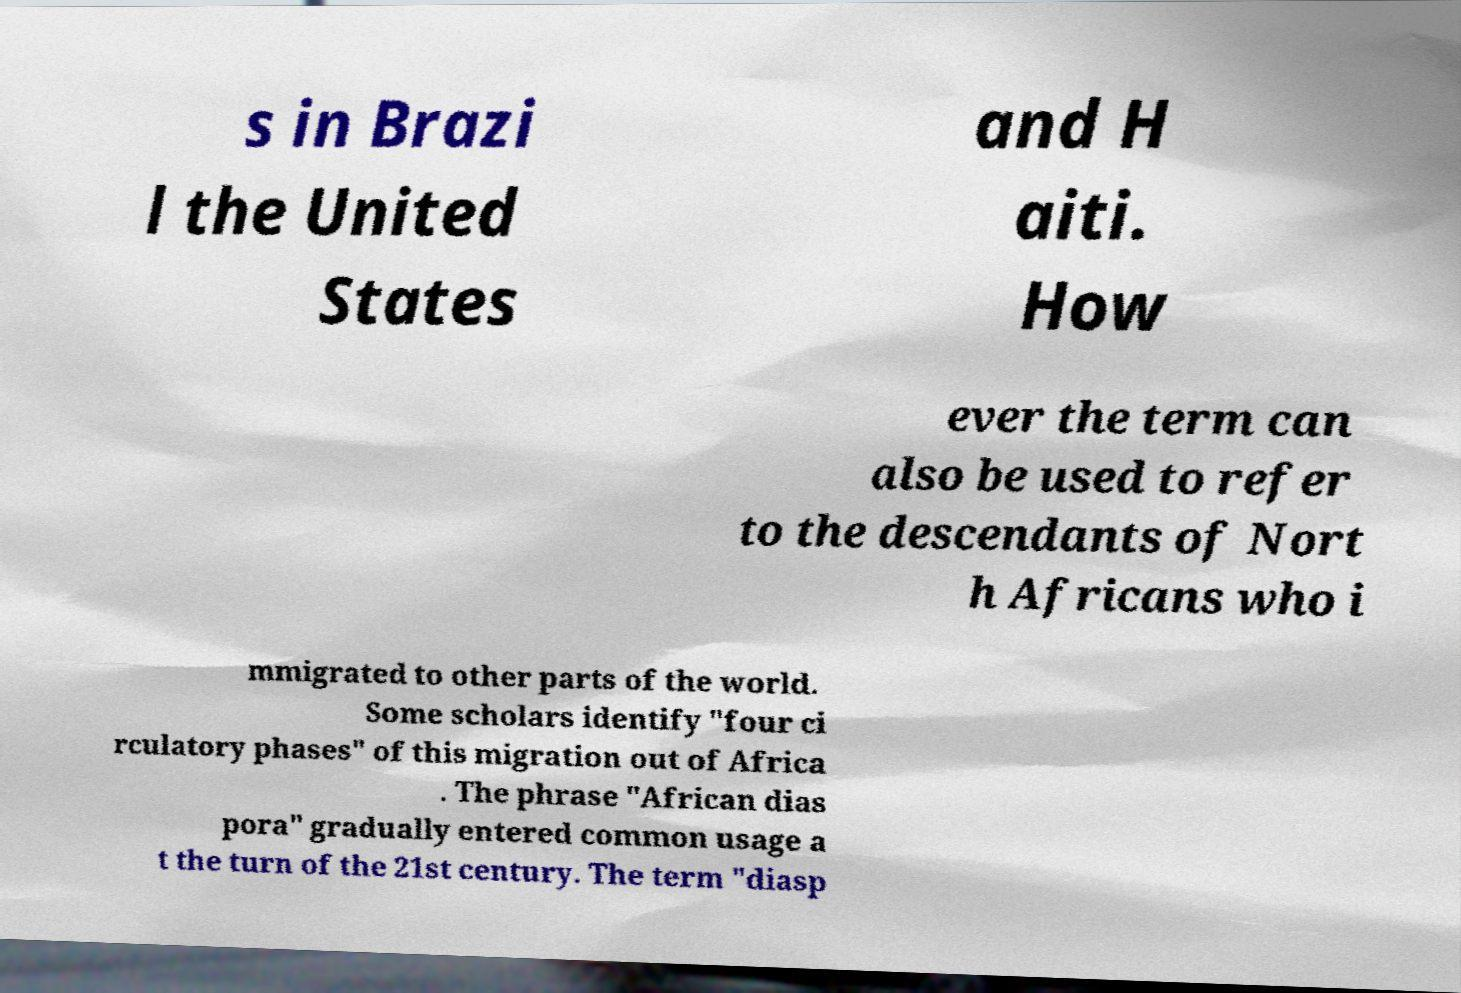Could you extract and type out the text from this image? s in Brazi l the United States and H aiti. How ever the term can also be used to refer to the descendants of Nort h Africans who i mmigrated to other parts of the world. Some scholars identify "four ci rculatory phases" of this migration out of Africa . The phrase "African dias pora" gradually entered common usage a t the turn of the 21st century. The term "diasp 